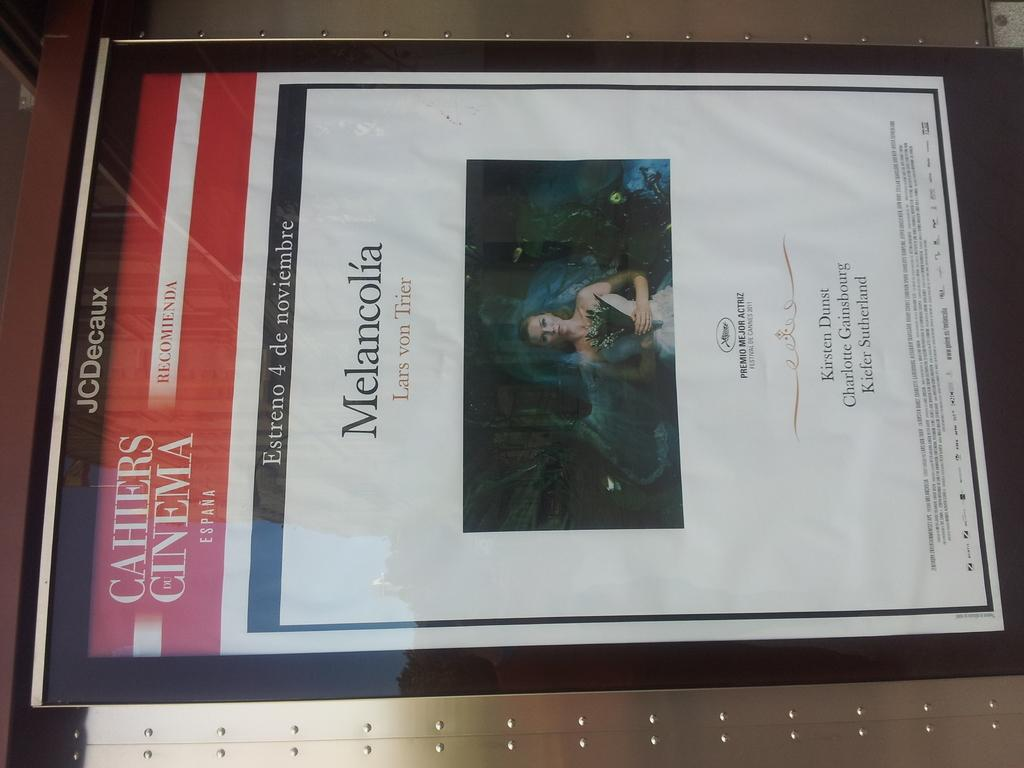<image>
Present a compact description of the photo's key features. An advertisement for the Spanish cinema which reads Melancolia. 